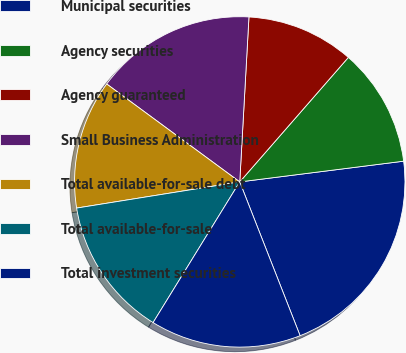Convert chart to OTSL. <chart><loc_0><loc_0><loc_500><loc_500><pie_chart><fcel>Municipal securities<fcel>Agency securities<fcel>Agency guaranteed<fcel>Small Business Administration<fcel>Total available-for-sale debt<fcel>Total available-for-sale<fcel>Total investment securities<nl><fcel>21.05%<fcel>11.58%<fcel>10.53%<fcel>15.79%<fcel>12.63%<fcel>13.68%<fcel>14.74%<nl></chart> 